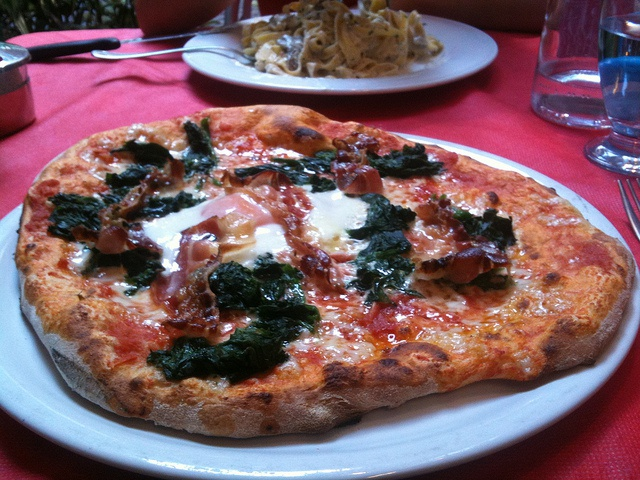Describe the objects in this image and their specific colors. I can see pizza in black, brown, maroon, and gray tones, dining table in black, violet, brown, and maroon tones, cup in black, purple, and brown tones, cup in black, navy, and purple tones, and wine glass in black, navy, and purple tones in this image. 